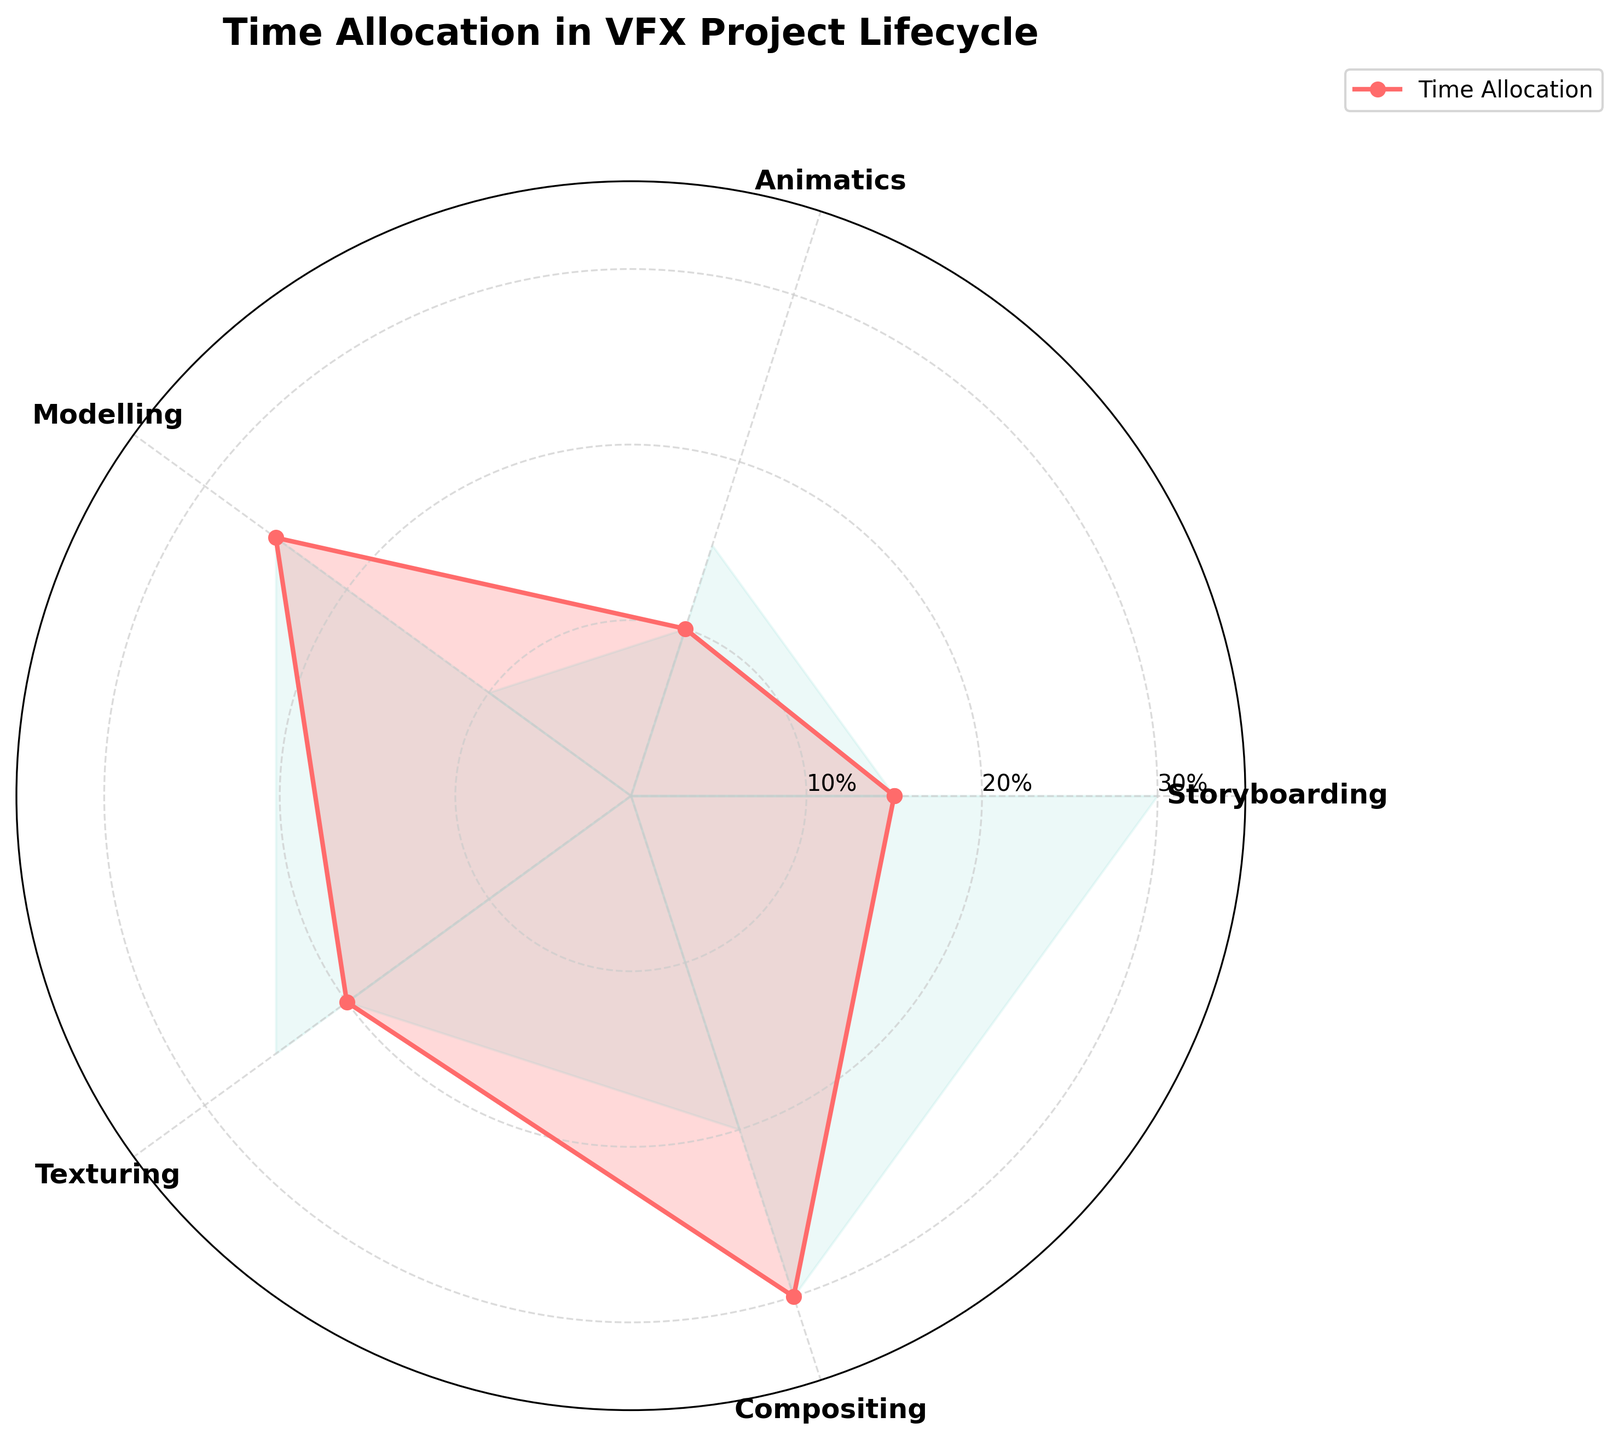What is the title of the radar chart? The title is usually placed at the top of the chart. In this case, it is "Time Allocation in VFX Project Lifecycle" as indicated by the plt.title() function.
Answer: Time Allocation in VFX Project Lifecycle How many different project phases are represented in the radar chart? The radar chart defines its categories and angles based on the total number of project phases. By observing the categories listed along the axes, we see Storyboarding, Animatics, Modelling, Texturing, and Compositing, making a total of 5 different project phases.
Answer: 5 Which project phase has the highest time allocation percentage and what is it? To find the highest time allocation, look at the values on the radar chart and identify the peak. The highest value is where the plot reaches its furthest point from the center. Compositing is at the farthest distance with a time allocation of 30%.
Answer: Compositing, 30% Which project phase has the lowest time allocation percentage and what is it? Identify the smallest value on the radar chart by finding the segment closest to the center. Animatics has the lowest allocation at 10%.
Answer: Animatics, 10% What is the total time allocation percentage for Storyboarding, Animatics, and Modelling combined? Add the given percentages for the three phases from the data: Storyboarding (15%), Animatics (10%), and Modelling (25%). So, 15 + 10 + 25 = 50%.
Answer: 50% How does the time allocated to Texturing compare to Storyboarding? Compare the percentages for Texturing and Storyboarding from the radar chart. Texturing is 20%, while Storyboarding is 15%. Thus, Texturing has 5% more time allocated than Storyboarding.
Answer: Texturing has 5% more than Storyboarding Is the outline of the radar chart filled with color? If yes, describe the color. The radar chart's plot and filled area can be observed. Yes, the outline is filled with color, and the filled region is a light shade different from the plot line. It uses a light pink for the fill area as indicated by the color in the plot instructions.
Answer: Yes, light pink What is the average time allocation percentage across all project phases? To calculate the average, add the percentages for all phases and divide by the number of phases. The sum of 15 + 10 + 25 + 20 + 30 is 100. Dividing by 5 phases, 100 / 5 = 20%.
Answer: 20% What's the total time allocation for Texturing and Compositing together? Add the percentages for Texturing (20%) and Compositing (30%). Their total is 20 + 30 = 50%.
Answer: 50% Which segments (project phases) exhibit values higher than the average time allocation? The average time allocation percentage calculated earlier is 20%. Identify all segments with values greater than 20%: these are Modelling (25%) and Compositing (30%).
Answer: Modelling and Compositing 